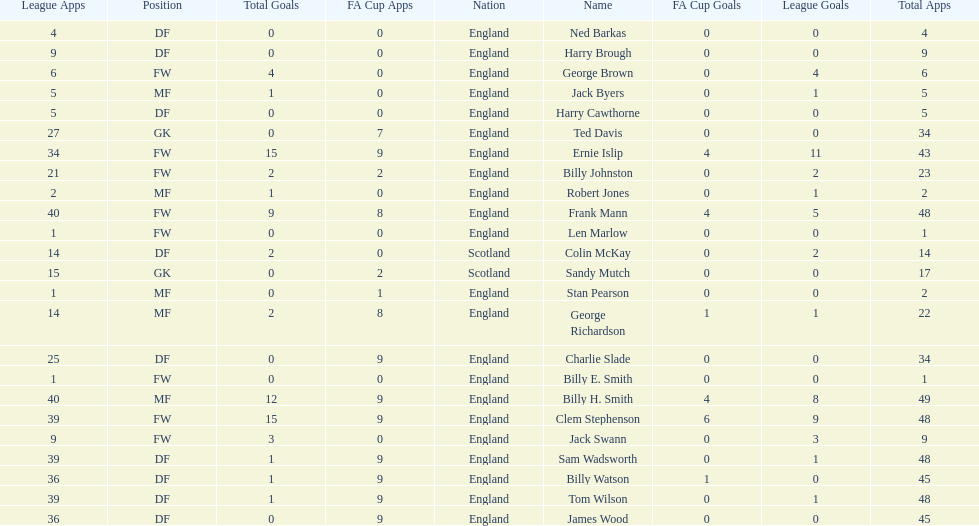What are the number of league apps ted davis has? 27. 